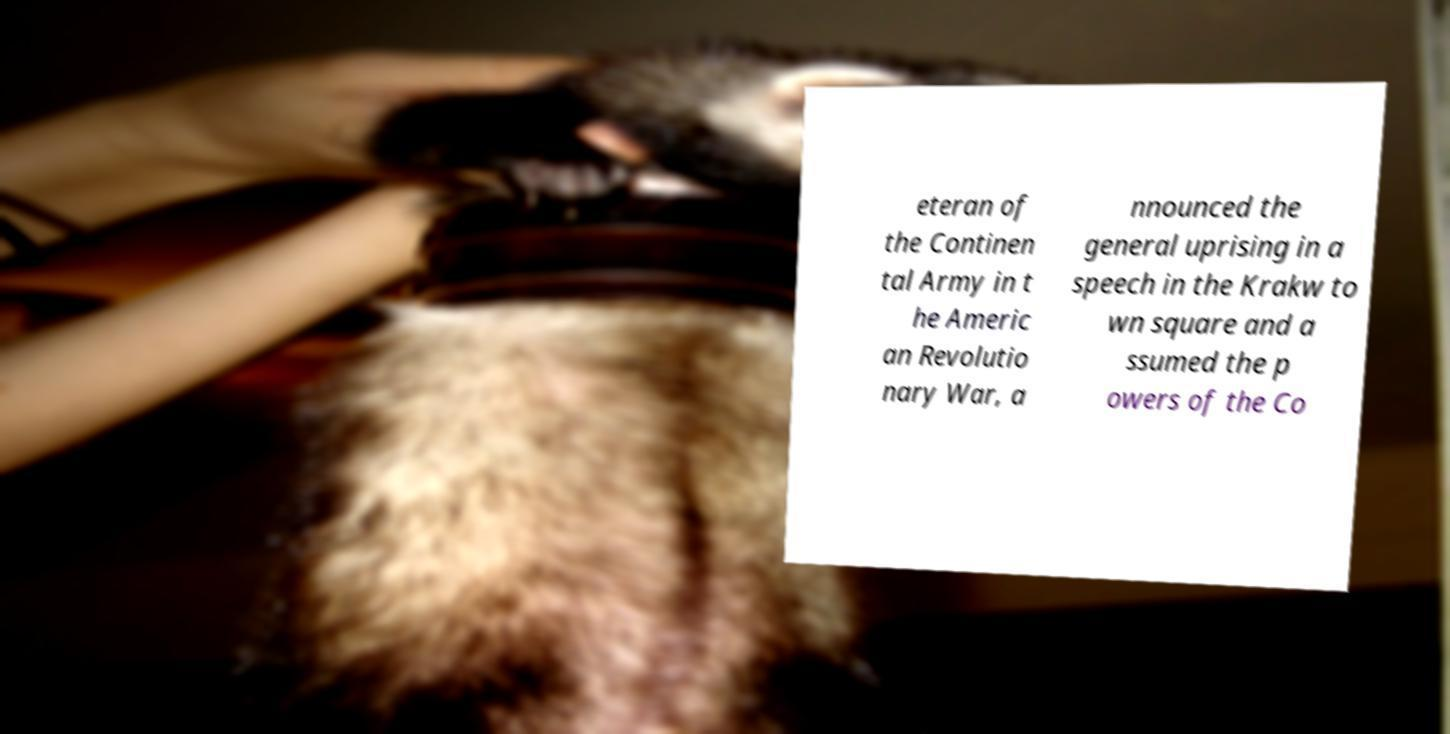Could you assist in decoding the text presented in this image and type it out clearly? eteran of the Continen tal Army in t he Americ an Revolutio nary War, a nnounced the general uprising in a speech in the Krakw to wn square and a ssumed the p owers of the Co 